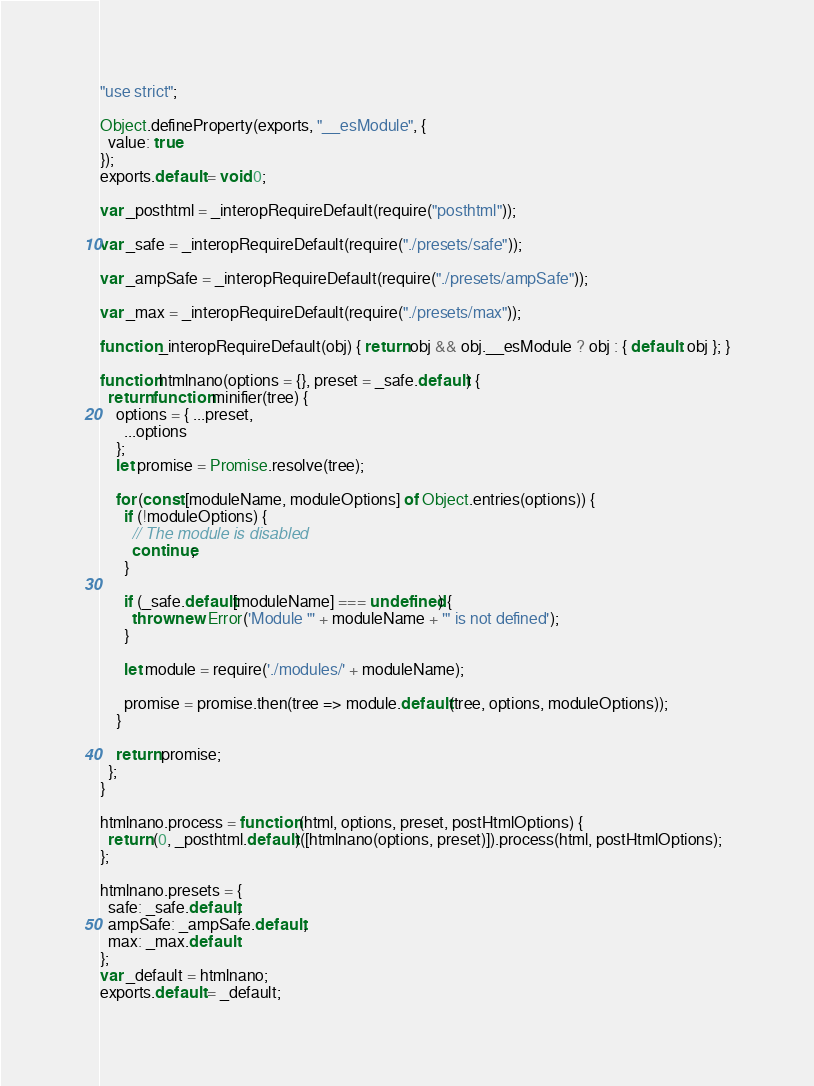Convert code to text. <code><loc_0><loc_0><loc_500><loc_500><_JavaScript_>"use strict";

Object.defineProperty(exports, "__esModule", {
  value: true
});
exports.default = void 0;

var _posthtml = _interopRequireDefault(require("posthtml"));

var _safe = _interopRequireDefault(require("./presets/safe"));

var _ampSafe = _interopRequireDefault(require("./presets/ampSafe"));

var _max = _interopRequireDefault(require("./presets/max"));

function _interopRequireDefault(obj) { return obj && obj.__esModule ? obj : { default: obj }; }

function htmlnano(options = {}, preset = _safe.default) {
  return function minifier(tree) {
    options = { ...preset,
      ...options
    };
    let promise = Promise.resolve(tree);

    for (const [moduleName, moduleOptions] of Object.entries(options)) {
      if (!moduleOptions) {
        // The module is disabled
        continue;
      }

      if (_safe.default[moduleName] === undefined) {
        throw new Error('Module "' + moduleName + '" is not defined');
      }

      let module = require('./modules/' + moduleName);

      promise = promise.then(tree => module.default(tree, options, moduleOptions));
    }

    return promise;
  };
}

htmlnano.process = function (html, options, preset, postHtmlOptions) {
  return (0, _posthtml.default)([htmlnano(options, preset)]).process(html, postHtmlOptions);
};

htmlnano.presets = {
  safe: _safe.default,
  ampSafe: _ampSafe.default,
  max: _max.default
};
var _default = htmlnano;
exports.default = _default;</code> 